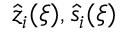<formula> <loc_0><loc_0><loc_500><loc_500>\hat { z } _ { i } ( \xi ) , \hat { s } _ { i } ( \xi )</formula> 